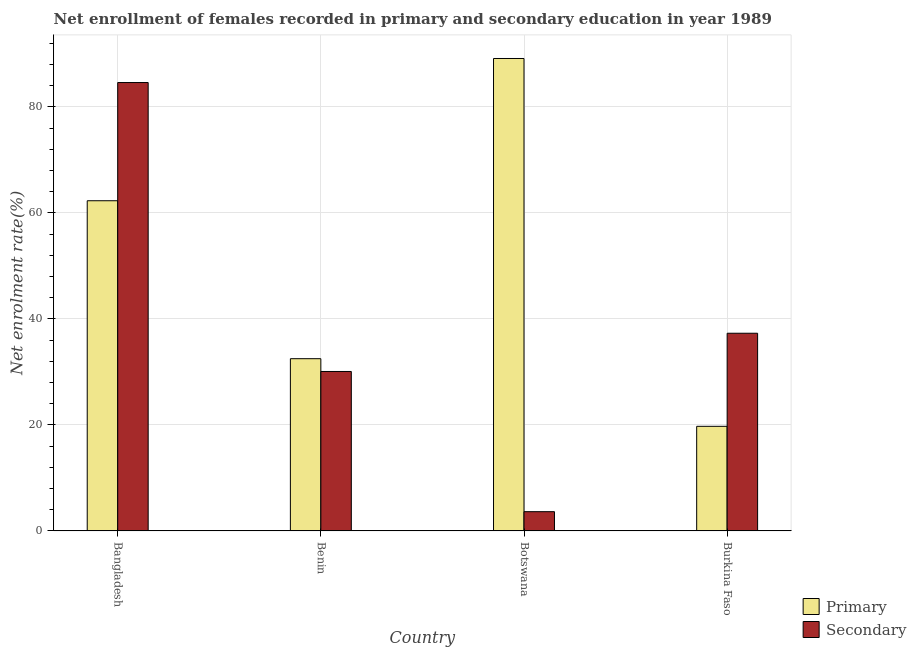How many different coloured bars are there?
Offer a terse response. 2. How many groups of bars are there?
Offer a very short reply. 4. Are the number of bars per tick equal to the number of legend labels?
Your answer should be compact. Yes. Are the number of bars on each tick of the X-axis equal?
Give a very brief answer. Yes. What is the label of the 1st group of bars from the left?
Your answer should be compact. Bangladesh. What is the enrollment rate in secondary education in Benin?
Give a very brief answer. 30.09. Across all countries, what is the maximum enrollment rate in primary education?
Your answer should be very brief. 89.15. Across all countries, what is the minimum enrollment rate in secondary education?
Provide a short and direct response. 3.63. In which country was the enrollment rate in secondary education minimum?
Provide a succinct answer. Botswana. What is the total enrollment rate in secondary education in the graph?
Your answer should be very brief. 155.65. What is the difference between the enrollment rate in secondary education in Bangladesh and that in Burkina Faso?
Ensure brevity in your answer.  47.31. What is the difference between the enrollment rate in primary education in Bangladesh and the enrollment rate in secondary education in Benin?
Provide a short and direct response. 32.22. What is the average enrollment rate in secondary education per country?
Ensure brevity in your answer.  38.91. What is the difference between the enrollment rate in primary education and enrollment rate in secondary education in Bangladesh?
Your answer should be compact. -22.31. What is the ratio of the enrollment rate in secondary education in Bangladesh to that in Burkina Faso?
Offer a very short reply. 2.27. Is the enrollment rate in primary education in Bangladesh less than that in Burkina Faso?
Provide a succinct answer. No. Is the difference between the enrollment rate in secondary education in Bangladesh and Benin greater than the difference between the enrollment rate in primary education in Bangladesh and Benin?
Give a very brief answer. Yes. What is the difference between the highest and the second highest enrollment rate in secondary education?
Your answer should be very brief. 47.31. What is the difference between the highest and the lowest enrollment rate in secondary education?
Make the answer very short. 80.98. What does the 1st bar from the left in Benin represents?
Give a very brief answer. Primary. What does the 1st bar from the right in Benin represents?
Give a very brief answer. Secondary. Are all the bars in the graph horizontal?
Keep it short and to the point. No. Where does the legend appear in the graph?
Make the answer very short. Bottom right. How are the legend labels stacked?
Give a very brief answer. Vertical. What is the title of the graph?
Ensure brevity in your answer.  Net enrollment of females recorded in primary and secondary education in year 1989. What is the label or title of the Y-axis?
Your answer should be compact. Net enrolment rate(%). What is the Net enrolment rate(%) of Primary in Bangladesh?
Your response must be concise. 62.31. What is the Net enrolment rate(%) of Secondary in Bangladesh?
Your answer should be compact. 84.62. What is the Net enrolment rate(%) in Primary in Benin?
Provide a short and direct response. 32.5. What is the Net enrolment rate(%) of Secondary in Benin?
Offer a terse response. 30.09. What is the Net enrolment rate(%) of Primary in Botswana?
Your answer should be compact. 89.15. What is the Net enrolment rate(%) of Secondary in Botswana?
Offer a terse response. 3.63. What is the Net enrolment rate(%) of Primary in Burkina Faso?
Provide a short and direct response. 19.74. What is the Net enrolment rate(%) in Secondary in Burkina Faso?
Give a very brief answer. 37.31. Across all countries, what is the maximum Net enrolment rate(%) of Primary?
Provide a short and direct response. 89.15. Across all countries, what is the maximum Net enrolment rate(%) in Secondary?
Your answer should be very brief. 84.62. Across all countries, what is the minimum Net enrolment rate(%) of Primary?
Your response must be concise. 19.74. Across all countries, what is the minimum Net enrolment rate(%) of Secondary?
Provide a succinct answer. 3.63. What is the total Net enrolment rate(%) in Primary in the graph?
Ensure brevity in your answer.  203.71. What is the total Net enrolment rate(%) of Secondary in the graph?
Make the answer very short. 155.65. What is the difference between the Net enrolment rate(%) in Primary in Bangladesh and that in Benin?
Your answer should be very brief. 29.81. What is the difference between the Net enrolment rate(%) of Secondary in Bangladesh and that in Benin?
Give a very brief answer. 54.53. What is the difference between the Net enrolment rate(%) of Primary in Bangladesh and that in Botswana?
Give a very brief answer. -26.84. What is the difference between the Net enrolment rate(%) in Secondary in Bangladesh and that in Botswana?
Provide a short and direct response. 80.98. What is the difference between the Net enrolment rate(%) of Primary in Bangladesh and that in Burkina Faso?
Your answer should be very brief. 42.57. What is the difference between the Net enrolment rate(%) of Secondary in Bangladesh and that in Burkina Faso?
Provide a short and direct response. 47.31. What is the difference between the Net enrolment rate(%) of Primary in Benin and that in Botswana?
Offer a terse response. -56.65. What is the difference between the Net enrolment rate(%) of Secondary in Benin and that in Botswana?
Offer a very short reply. 26.46. What is the difference between the Net enrolment rate(%) of Primary in Benin and that in Burkina Faso?
Your answer should be compact. 12.76. What is the difference between the Net enrolment rate(%) of Secondary in Benin and that in Burkina Faso?
Your response must be concise. -7.22. What is the difference between the Net enrolment rate(%) in Primary in Botswana and that in Burkina Faso?
Offer a terse response. 69.41. What is the difference between the Net enrolment rate(%) in Secondary in Botswana and that in Burkina Faso?
Provide a succinct answer. -33.67. What is the difference between the Net enrolment rate(%) in Primary in Bangladesh and the Net enrolment rate(%) in Secondary in Benin?
Your answer should be very brief. 32.22. What is the difference between the Net enrolment rate(%) in Primary in Bangladesh and the Net enrolment rate(%) in Secondary in Botswana?
Offer a terse response. 58.68. What is the difference between the Net enrolment rate(%) in Primary in Bangladesh and the Net enrolment rate(%) in Secondary in Burkina Faso?
Your answer should be very brief. 25. What is the difference between the Net enrolment rate(%) in Primary in Benin and the Net enrolment rate(%) in Secondary in Botswana?
Your answer should be compact. 28.87. What is the difference between the Net enrolment rate(%) of Primary in Benin and the Net enrolment rate(%) of Secondary in Burkina Faso?
Offer a terse response. -4.8. What is the difference between the Net enrolment rate(%) of Primary in Botswana and the Net enrolment rate(%) of Secondary in Burkina Faso?
Give a very brief answer. 51.85. What is the average Net enrolment rate(%) of Primary per country?
Provide a short and direct response. 50.93. What is the average Net enrolment rate(%) of Secondary per country?
Make the answer very short. 38.91. What is the difference between the Net enrolment rate(%) of Primary and Net enrolment rate(%) of Secondary in Bangladesh?
Your response must be concise. -22.31. What is the difference between the Net enrolment rate(%) in Primary and Net enrolment rate(%) in Secondary in Benin?
Make the answer very short. 2.41. What is the difference between the Net enrolment rate(%) of Primary and Net enrolment rate(%) of Secondary in Botswana?
Provide a succinct answer. 85.52. What is the difference between the Net enrolment rate(%) of Primary and Net enrolment rate(%) of Secondary in Burkina Faso?
Provide a short and direct response. -17.56. What is the ratio of the Net enrolment rate(%) of Primary in Bangladesh to that in Benin?
Keep it short and to the point. 1.92. What is the ratio of the Net enrolment rate(%) of Secondary in Bangladesh to that in Benin?
Ensure brevity in your answer.  2.81. What is the ratio of the Net enrolment rate(%) in Primary in Bangladesh to that in Botswana?
Your answer should be compact. 0.7. What is the ratio of the Net enrolment rate(%) in Secondary in Bangladesh to that in Botswana?
Ensure brevity in your answer.  23.28. What is the ratio of the Net enrolment rate(%) of Primary in Bangladesh to that in Burkina Faso?
Your answer should be very brief. 3.16. What is the ratio of the Net enrolment rate(%) of Secondary in Bangladesh to that in Burkina Faso?
Your answer should be compact. 2.27. What is the ratio of the Net enrolment rate(%) of Primary in Benin to that in Botswana?
Your answer should be very brief. 0.36. What is the ratio of the Net enrolment rate(%) in Secondary in Benin to that in Botswana?
Provide a short and direct response. 8.28. What is the ratio of the Net enrolment rate(%) in Primary in Benin to that in Burkina Faso?
Your answer should be very brief. 1.65. What is the ratio of the Net enrolment rate(%) of Secondary in Benin to that in Burkina Faso?
Your response must be concise. 0.81. What is the ratio of the Net enrolment rate(%) of Primary in Botswana to that in Burkina Faso?
Offer a very short reply. 4.52. What is the ratio of the Net enrolment rate(%) of Secondary in Botswana to that in Burkina Faso?
Provide a succinct answer. 0.1. What is the difference between the highest and the second highest Net enrolment rate(%) in Primary?
Ensure brevity in your answer.  26.84. What is the difference between the highest and the second highest Net enrolment rate(%) in Secondary?
Provide a short and direct response. 47.31. What is the difference between the highest and the lowest Net enrolment rate(%) of Primary?
Provide a short and direct response. 69.41. What is the difference between the highest and the lowest Net enrolment rate(%) of Secondary?
Provide a short and direct response. 80.98. 